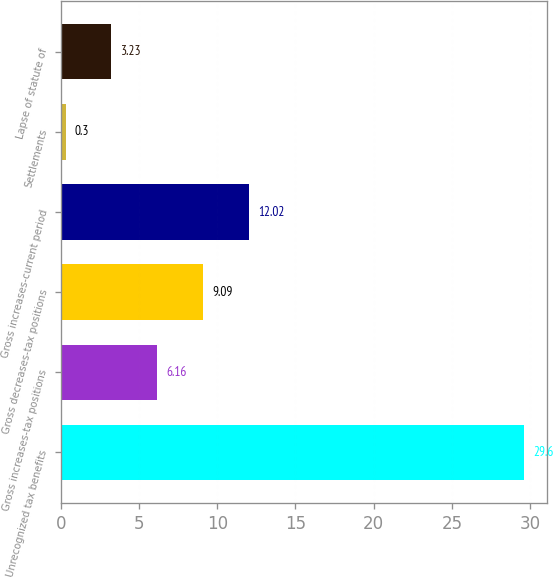<chart> <loc_0><loc_0><loc_500><loc_500><bar_chart><fcel>Unrecognized tax benefits<fcel>Gross increases-tax positions<fcel>Gross decreases-tax positions<fcel>Gross increases-current period<fcel>Settlements<fcel>Lapse of statute of<nl><fcel>29.6<fcel>6.16<fcel>9.09<fcel>12.02<fcel>0.3<fcel>3.23<nl></chart> 